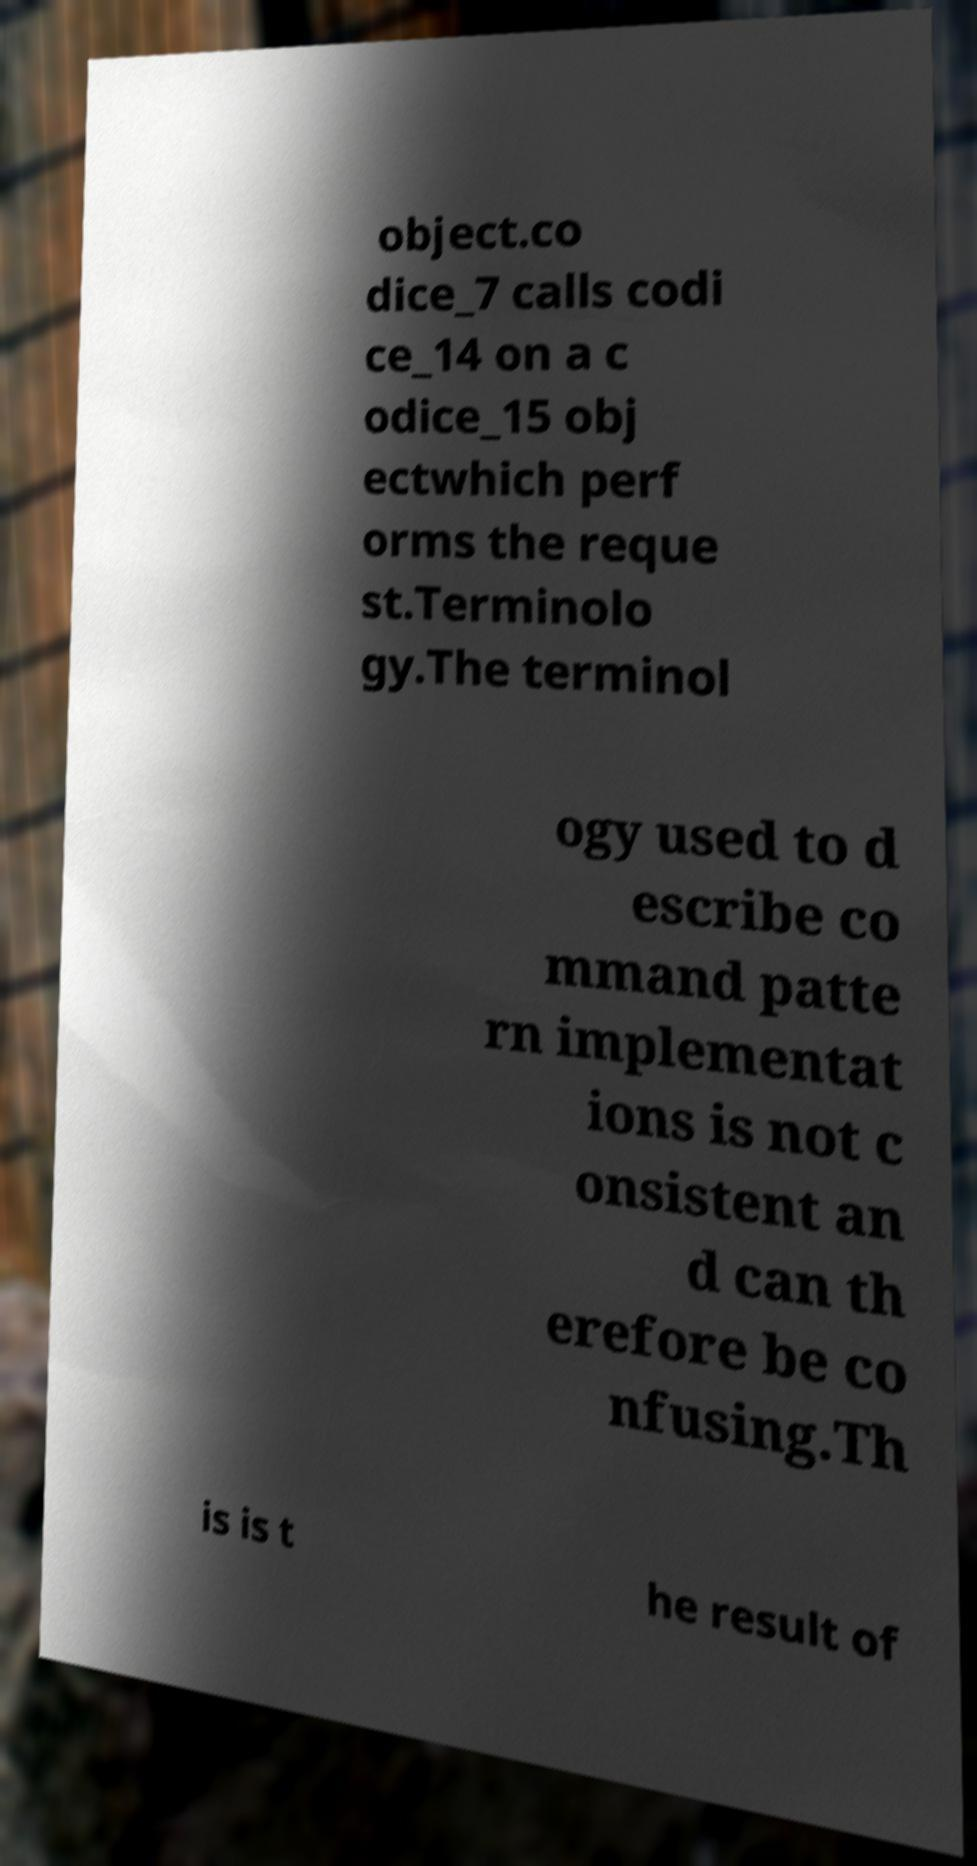Please identify and transcribe the text found in this image. object.co dice_7 calls codi ce_14 on a c odice_15 obj ectwhich perf orms the reque st.Terminolo gy.The terminol ogy used to d escribe co mmand patte rn implementat ions is not c onsistent an d can th erefore be co nfusing.Th is is t he result of 